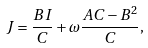Convert formula to latex. <formula><loc_0><loc_0><loc_500><loc_500>J = \frac { B I } { C } + \omega \frac { A C - B ^ { 2 } } { C } ,</formula> 